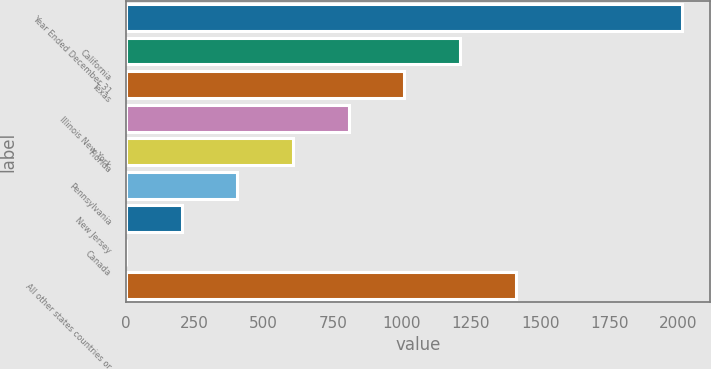Convert chart to OTSL. <chart><loc_0><loc_0><loc_500><loc_500><bar_chart><fcel>Year Ended December 31<fcel>California<fcel>Texas<fcel>Illinois New York<fcel>Florida<fcel>Pennsylvania<fcel>New Jersey<fcel>Canada<fcel>All other states countries or<nl><fcel>2015<fcel>1209.88<fcel>1008.6<fcel>807.32<fcel>606.04<fcel>404.76<fcel>203.48<fcel>2.2<fcel>1411.16<nl></chart> 